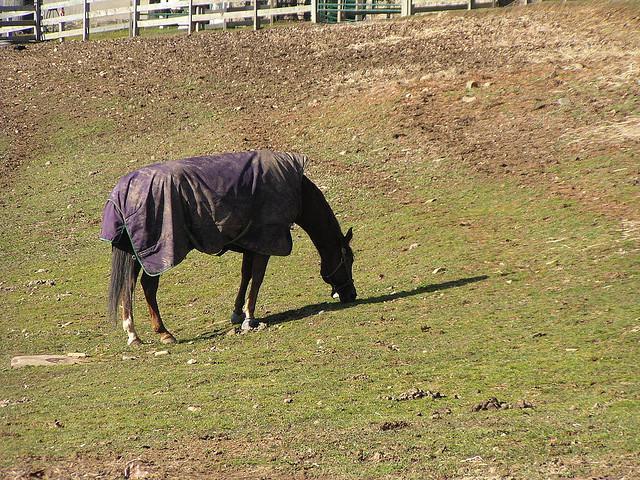How many colors are in the horse's mane?
Give a very brief answer. 1. How many horses are there in this picture?
Give a very brief answer. 1. How many horses are there?
Give a very brief answer. 1. How many red cars can you spot?
Give a very brief answer. 0. 